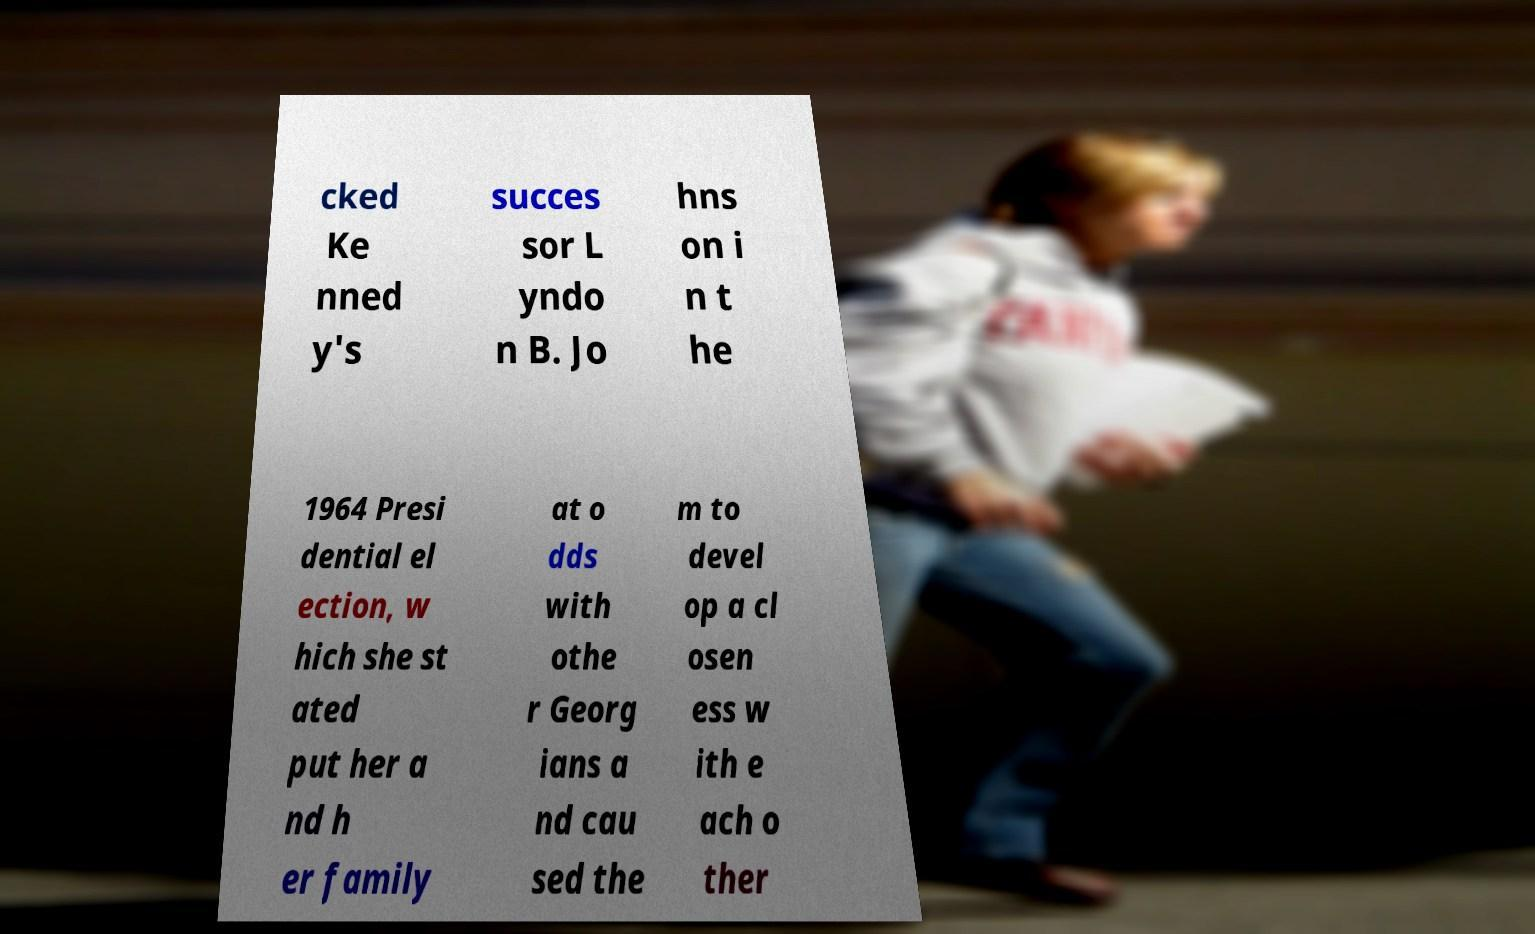Can you read and provide the text displayed in the image?This photo seems to have some interesting text. Can you extract and type it out for me? cked Ke nned y's succes sor L yndo n B. Jo hns on i n t he 1964 Presi dential el ection, w hich she st ated put her a nd h er family at o dds with othe r Georg ians a nd cau sed the m to devel op a cl osen ess w ith e ach o ther 